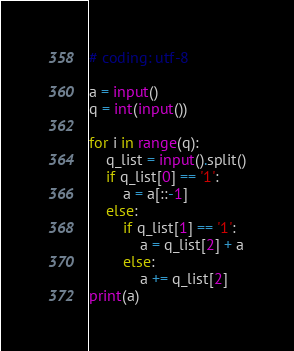<code> <loc_0><loc_0><loc_500><loc_500><_Python_># coding: utf-8

a = input()
q = int(input())

for i in range(q):
    q_list = input().split()
    if q_list[0] == '1':
        a = a[::-1]
    else:
        if q_list[1] == '1':
            a = q_list[2] + a
        else:
            a += q_list[2]
print(a)
</code> 